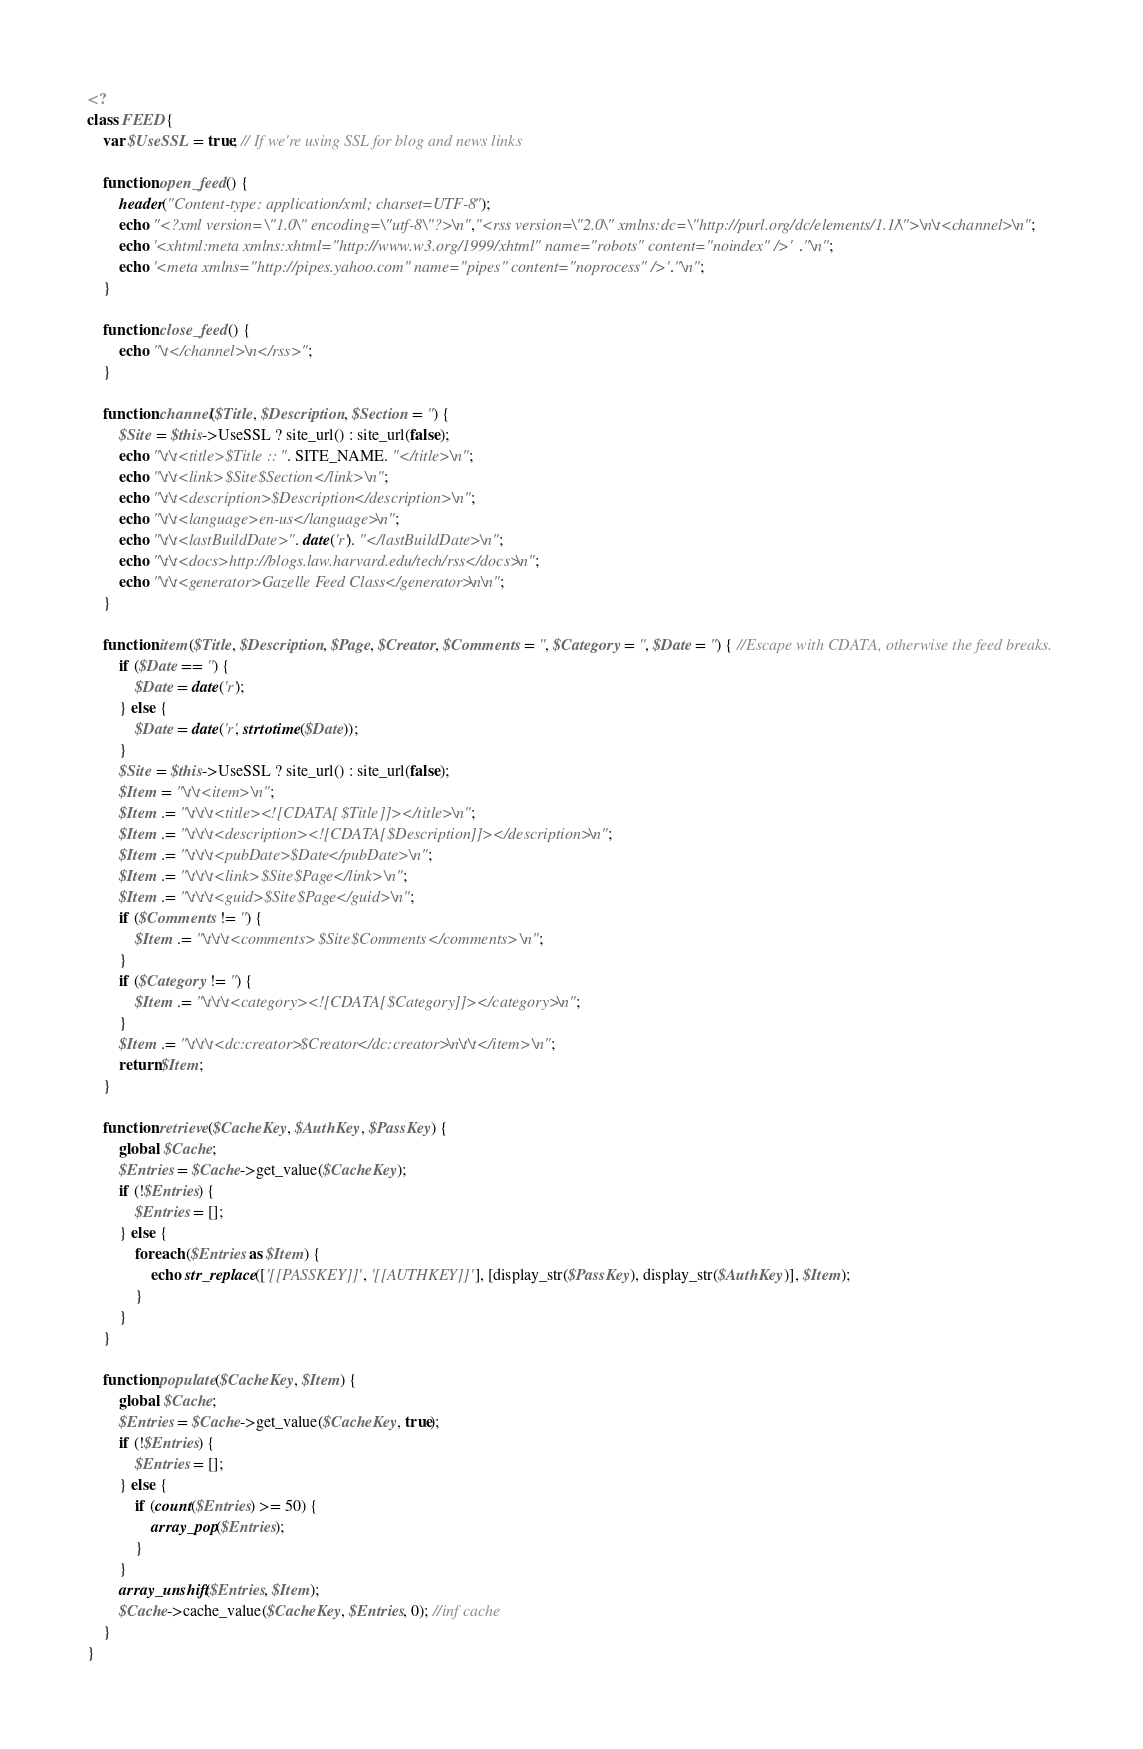<code> <loc_0><loc_0><loc_500><loc_500><_PHP_><?
class FEED {
	var $UseSSL = true; // If we're using SSL for blog and news links

	function open_feed() {
		header("Content-type: application/xml; charset=UTF-8");
		echo "<?xml version=\"1.0\" encoding=\"utf-8\"?>\n","<rss version=\"2.0\" xmlns:dc=\"http://purl.org/dc/elements/1.1/\">\n\t<channel>\n";
		echo '<xhtml:meta xmlns:xhtml="http://www.w3.org/1999/xhtml" name="robots" content="noindex" />'."\n";
		echo '<meta xmlns="http://pipes.yahoo.com" name="pipes" content="noprocess" />'."\n";
	}

	function close_feed() {
		echo "\t</channel>\n</rss>";
	}

	function channel($Title, $Description, $Section = '') {
		$Site = $this->UseSSL ? site_url() : site_url(false);
		echo "\t\t<title>$Title :: ". SITE_NAME. "</title>\n";
		echo "\t\t<link>$Site$Section</link>\n";
		echo "\t\t<description>$Description</description>\n";
		echo "\t\t<language>en-us</language>\n";
		echo "\t\t<lastBuildDate>". date('r'). "</lastBuildDate>\n";
		echo "\t\t<docs>http://blogs.law.harvard.edu/tech/rss</docs>\n";
		echo "\t\t<generator>Gazelle Feed Class</generator>\n\n";
	}

	function item($Title, $Description, $Page, $Creator, $Comments = '', $Category = '', $Date = '') { //Escape with CDATA, otherwise the feed breaks.
		if ($Date == '') {
			$Date = date('r');
		} else {
			$Date = date('r', strtotime($Date));
		}
		$Site = $this->UseSSL ? site_url() : site_url(false);
		$Item = "\t\t<item>\n";
		$Item .= "\t\t\t<title><![CDATA[$Title]]></title>\n";
		$Item .= "\t\t\t<description><![CDATA[$Description]]></description>\n";
		$Item .= "\t\t\t<pubDate>$Date</pubDate>\n";
		$Item .= "\t\t\t<link>$Site$Page</link>\n";
		$Item .= "\t\t\t<guid>$Site$Page</guid>\n";
		if ($Comments != '') {
			$Item .= "\t\t\t<comments>$Site$Comments</comments>\n";
		}
		if ($Category != '') {
			$Item .= "\t\t\t<category><![CDATA[$Category]]></category>\n";
		}
		$Item .= "\t\t\t<dc:creator>$Creator</dc:creator>\n\t\t</item>\n";
		return $Item;
	}

	function retrieve($CacheKey, $AuthKey, $PassKey) {
		global $Cache;
		$Entries = $Cache->get_value($CacheKey);
		if (!$Entries) {
			$Entries = [];
		} else {
			foreach ($Entries as $Item) {
				echo str_replace(['[[PASSKEY]]', '[[AUTHKEY]]'], [display_str($PassKey), display_str($AuthKey)], $Item);
			}
		}
	}

	function populate($CacheKey, $Item) {
		global $Cache;
		$Entries = $Cache->get_value($CacheKey, true);
		if (!$Entries) {
			$Entries = [];
		} else {
			if (count($Entries) >= 50) {
				array_pop($Entries);
			}
		}
		array_unshift($Entries, $Item);
		$Cache->cache_value($CacheKey, $Entries, 0); //inf cache
	}
}
</code> 